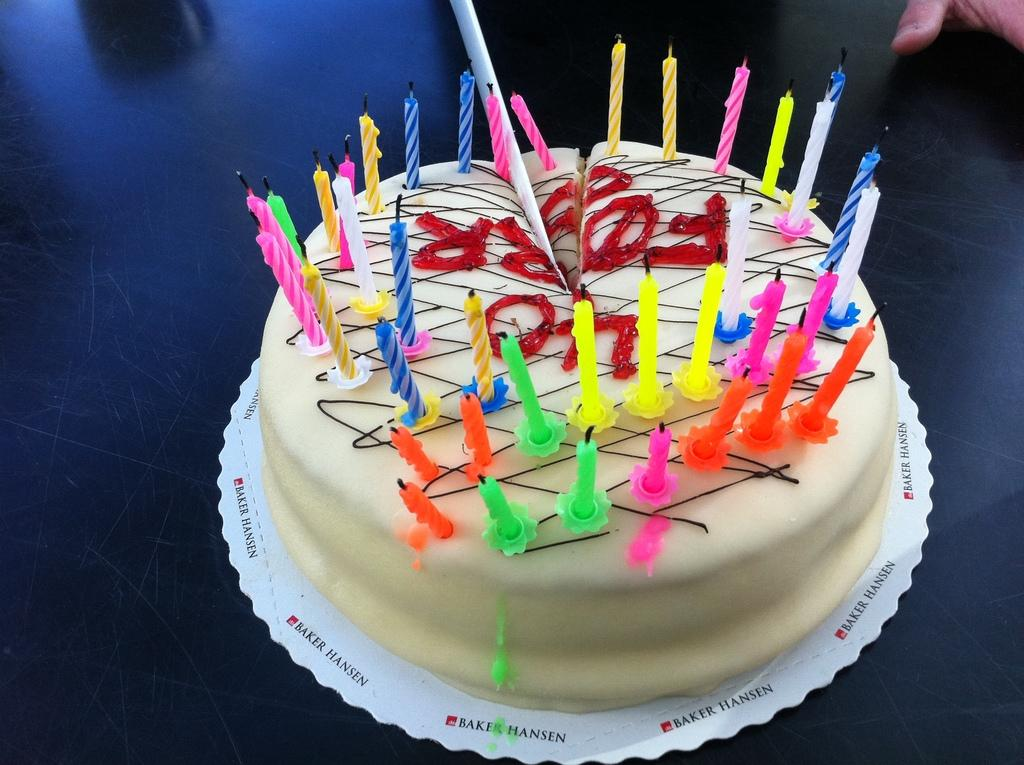What is the main subject in the center of the image? There is a cake in the center of the image. What is placed on top of the cake? There are many candles on the top of the cake. What is the color of the surface on which the cake is placed? The cake is placed on a black surface. How many passengers are sitting around the cake in the image? There are no passengers present in the image; it only features a cake with candles on a black surface. 